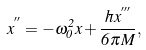<formula> <loc_0><loc_0><loc_500><loc_500>x ^ { ^ { \prime \prime } } = - \omega _ { 0 } ^ { 2 } x + { \frac { \hbar { x } ^ { ^ { \prime \prime \prime } } } { 6 \pi M } } ,</formula> 